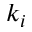Convert formula to latex. <formula><loc_0><loc_0><loc_500><loc_500>k _ { i }</formula> 